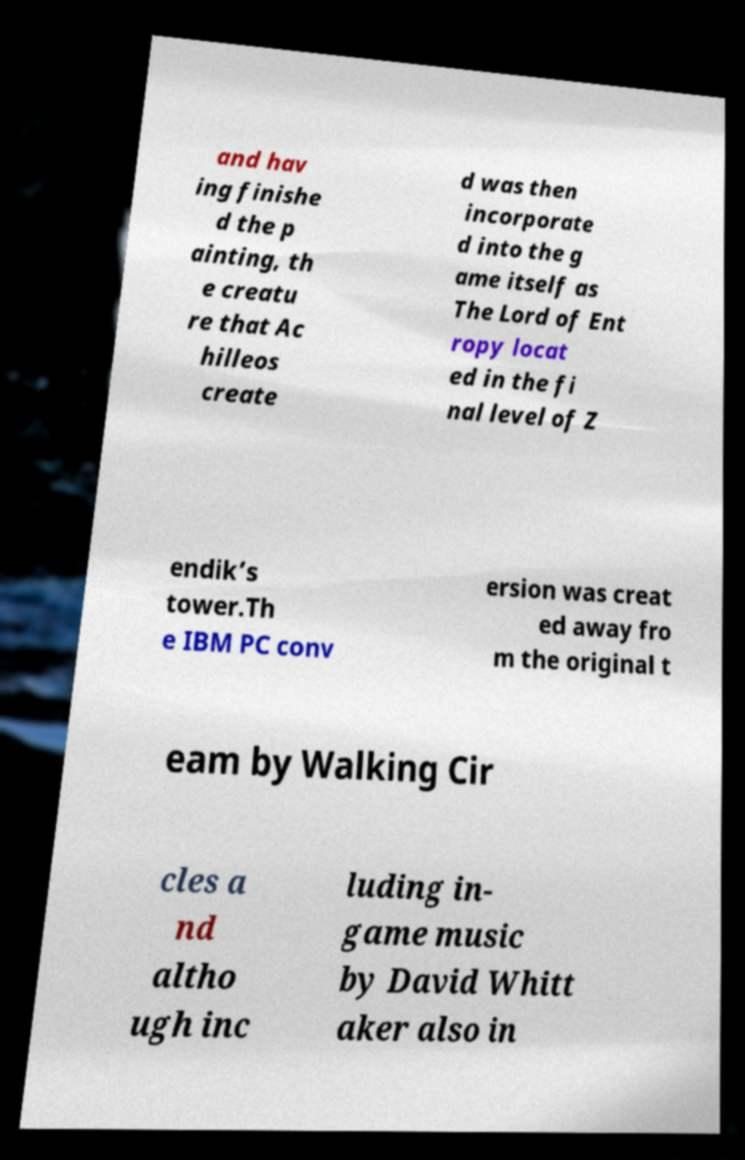Please identify and transcribe the text found in this image. and hav ing finishe d the p ainting, th e creatu re that Ac hilleos create d was then incorporate d into the g ame itself as The Lord of Ent ropy locat ed in the fi nal level of Z endik’s tower.Th e IBM PC conv ersion was creat ed away fro m the original t eam by Walking Cir cles a nd altho ugh inc luding in- game music by David Whitt aker also in 